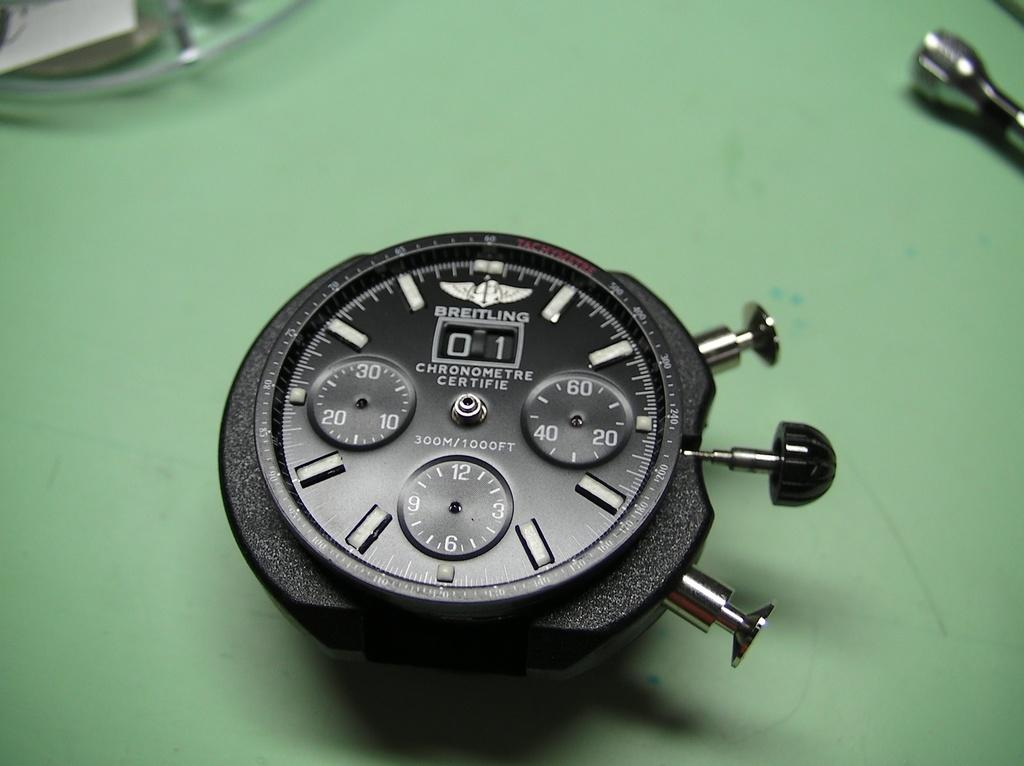<image>
Create a compact narrative representing the image presented. A black Breitling watch with no case or band is on a green table. 